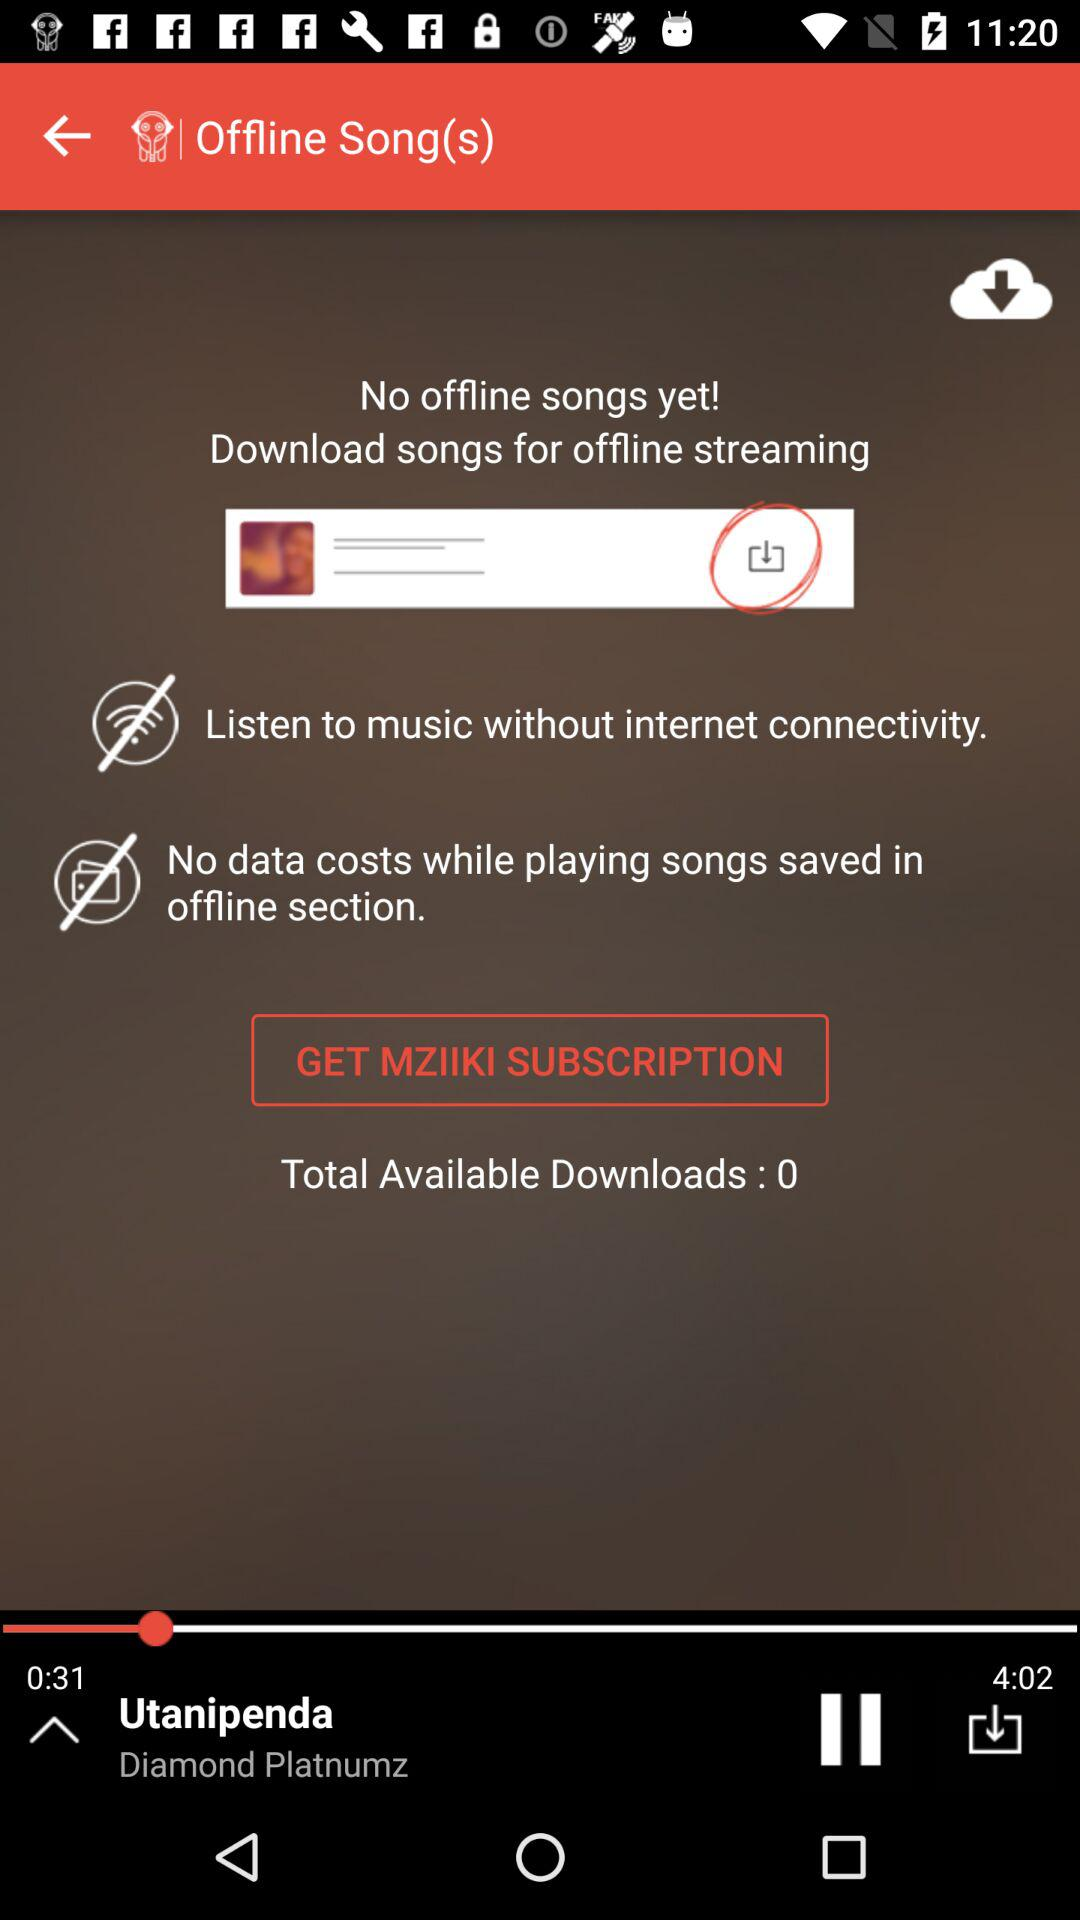Who's the singer of "Utanipenda"? The singer is Diamond Platnumz. 